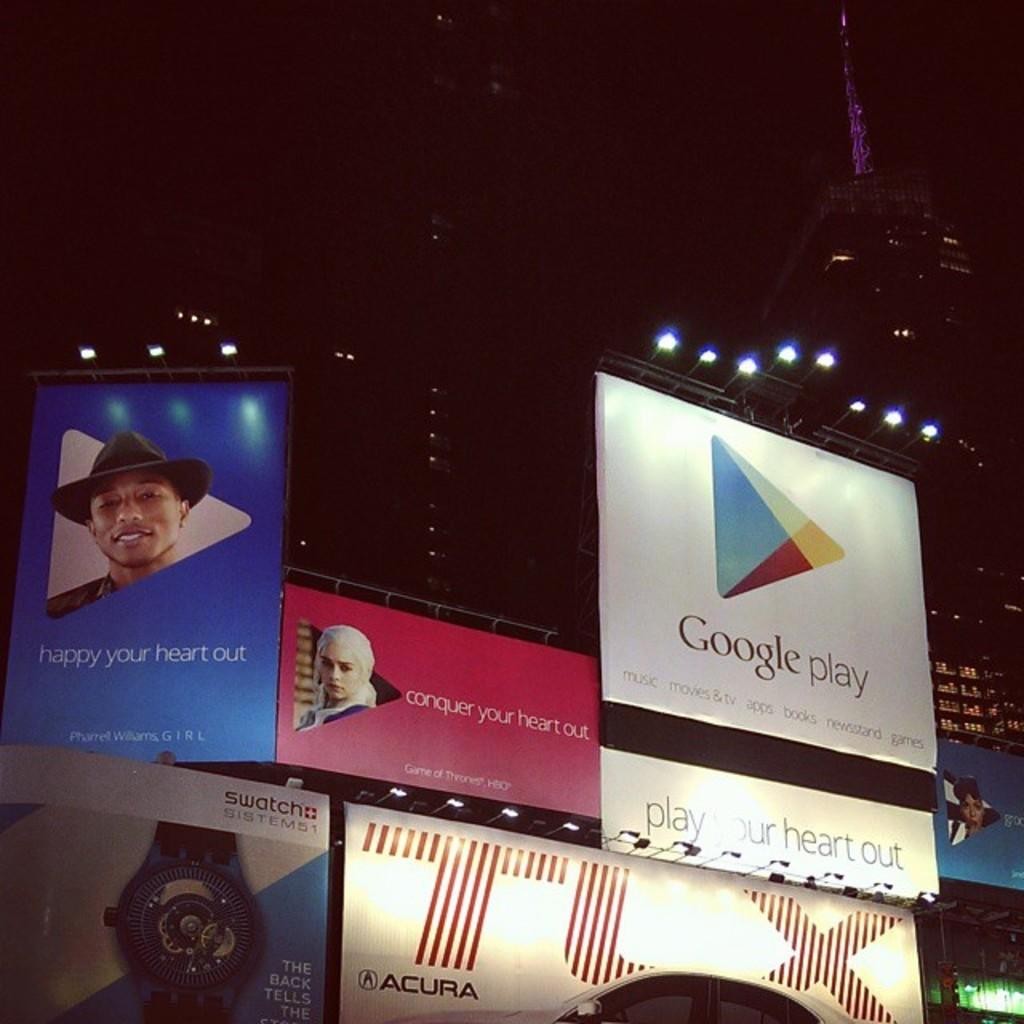<image>
Relay a brief, clear account of the picture shown. many signs are hanging up, including a google play ad 